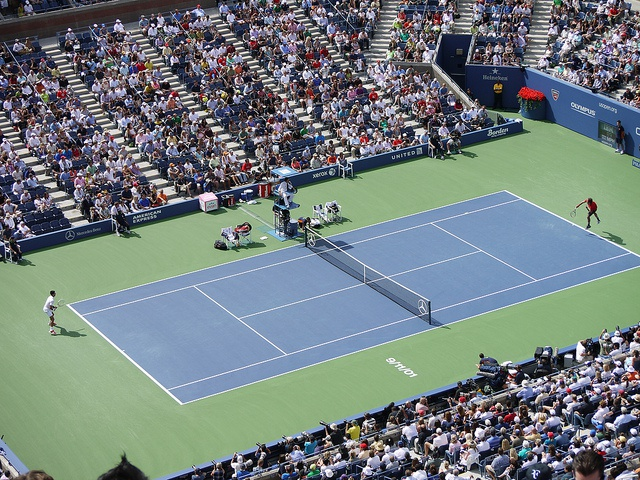Describe the objects in this image and their specific colors. I can see people in black, gray, darkgray, and lightgray tones, people in black, darkgray, lightgray, and gray tones, people in black, darkgray, lightgray, and gray tones, people in black, maroon, darkgray, and gray tones, and people in black, darkgray, gray, and lavender tones in this image. 